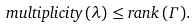Convert formula to latex. <formula><loc_0><loc_0><loc_500><loc_500>m u l t i p l i c i t y \, ( \lambda ) \leq r a n k \, ( \Gamma ) .</formula> 